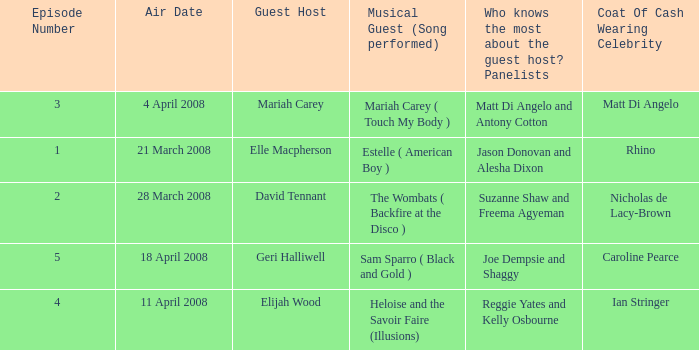Name the least number of episodes for the panelists of reggie yates and kelly osbourne 4.0. 